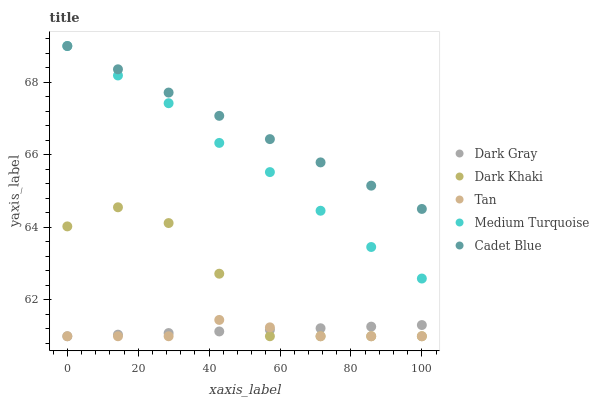Does Tan have the minimum area under the curve?
Answer yes or no. Yes. Does Cadet Blue have the maximum area under the curve?
Answer yes or no. Yes. Does Dark Khaki have the minimum area under the curve?
Answer yes or no. No. Does Dark Khaki have the maximum area under the curve?
Answer yes or no. No. Is Cadet Blue the smoothest?
Answer yes or no. Yes. Is Dark Khaki the roughest?
Answer yes or no. Yes. Is Tan the smoothest?
Answer yes or no. No. Is Tan the roughest?
Answer yes or no. No. Does Dark Gray have the lowest value?
Answer yes or no. Yes. Does Cadet Blue have the lowest value?
Answer yes or no. No. Does Medium Turquoise have the highest value?
Answer yes or no. Yes. Does Dark Khaki have the highest value?
Answer yes or no. No. Is Dark Khaki less than Medium Turquoise?
Answer yes or no. Yes. Is Medium Turquoise greater than Tan?
Answer yes or no. Yes. Does Dark Khaki intersect Tan?
Answer yes or no. Yes. Is Dark Khaki less than Tan?
Answer yes or no. No. Is Dark Khaki greater than Tan?
Answer yes or no. No. Does Dark Khaki intersect Medium Turquoise?
Answer yes or no. No. 